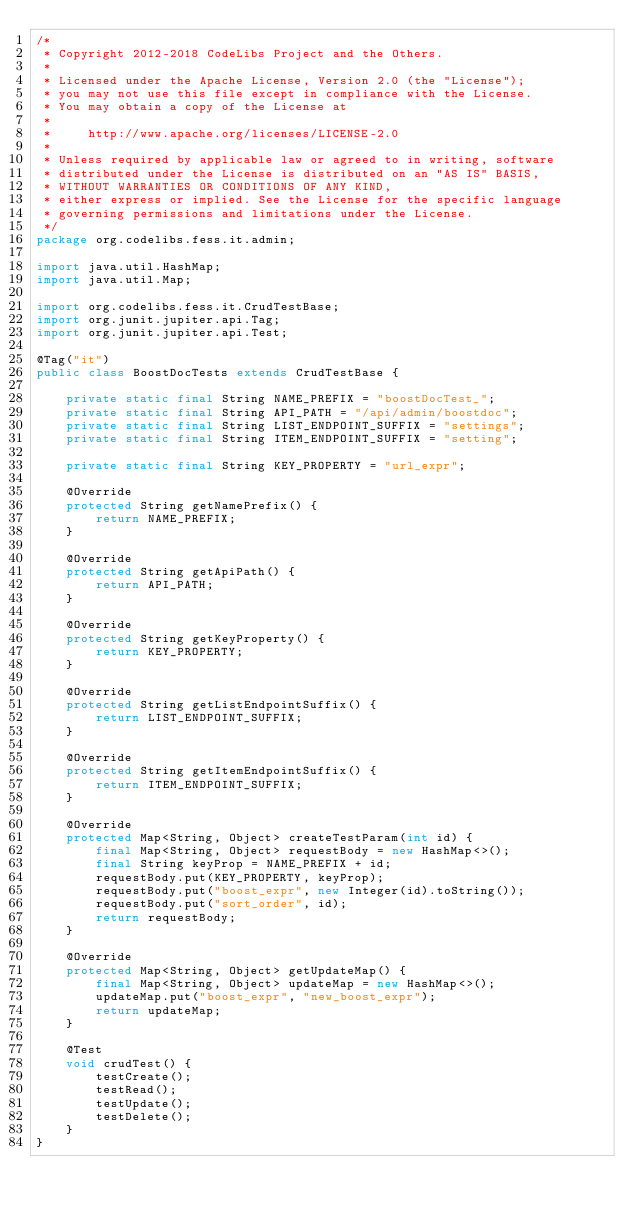Convert code to text. <code><loc_0><loc_0><loc_500><loc_500><_Java_>/*
 * Copyright 2012-2018 CodeLibs Project and the Others.
 *
 * Licensed under the Apache License, Version 2.0 (the "License");
 * you may not use this file except in compliance with the License.
 * You may obtain a copy of the License at
 *
 *     http://www.apache.org/licenses/LICENSE-2.0
 *
 * Unless required by applicable law or agreed to in writing, software
 * distributed under the License is distributed on an "AS IS" BASIS,
 * WITHOUT WARRANTIES OR CONDITIONS OF ANY KIND,
 * either express or implied. See the License for the specific language
 * governing permissions and limitations under the License.
 */
package org.codelibs.fess.it.admin;

import java.util.HashMap;
import java.util.Map;

import org.codelibs.fess.it.CrudTestBase;
import org.junit.jupiter.api.Tag;
import org.junit.jupiter.api.Test;

@Tag("it")
public class BoostDocTests extends CrudTestBase {

    private static final String NAME_PREFIX = "boostDocTest_";
    private static final String API_PATH = "/api/admin/boostdoc";
    private static final String LIST_ENDPOINT_SUFFIX = "settings";
    private static final String ITEM_ENDPOINT_SUFFIX = "setting";

    private static final String KEY_PROPERTY = "url_expr";

    @Override
    protected String getNamePrefix() {
        return NAME_PREFIX;
    }

    @Override
    protected String getApiPath() {
        return API_PATH;
    }

    @Override
    protected String getKeyProperty() {
        return KEY_PROPERTY;
    }

    @Override
    protected String getListEndpointSuffix() {
        return LIST_ENDPOINT_SUFFIX;
    }

    @Override
    protected String getItemEndpointSuffix() {
        return ITEM_ENDPOINT_SUFFIX;
    }

    @Override
    protected Map<String, Object> createTestParam(int id) {
        final Map<String, Object> requestBody = new HashMap<>();
        final String keyProp = NAME_PREFIX + id;
        requestBody.put(KEY_PROPERTY, keyProp);
        requestBody.put("boost_expr", new Integer(id).toString());
        requestBody.put("sort_order", id);
        return requestBody;
    }

    @Override
    protected Map<String, Object> getUpdateMap() {
        final Map<String, Object> updateMap = new HashMap<>();
        updateMap.put("boost_expr", "new_boost_expr");
        return updateMap;
    }

    @Test
    void crudTest() {
        testCreate();
        testRead();
        testUpdate();
        testDelete();
    }
}
</code> 